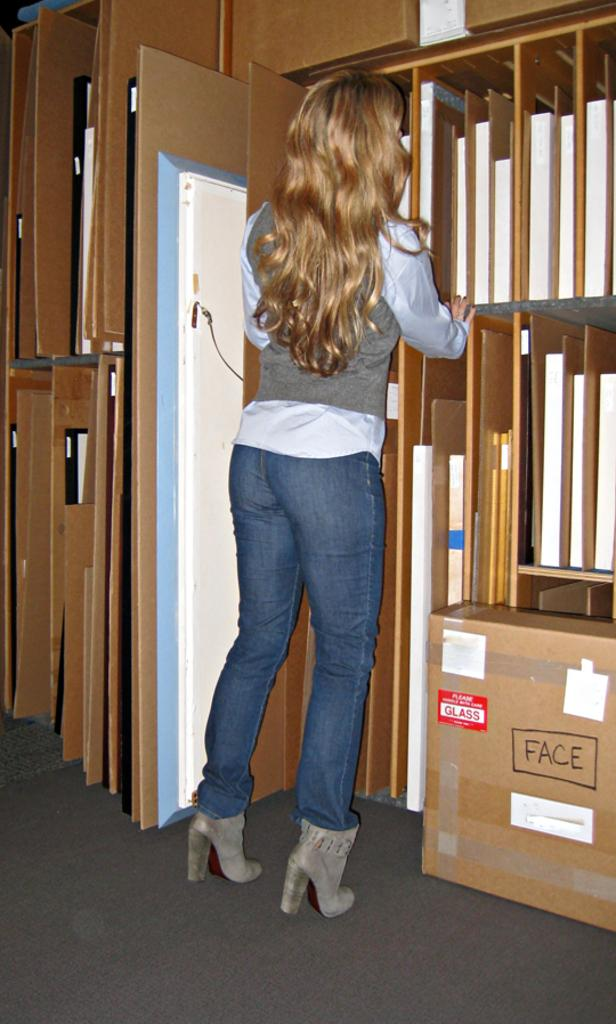<image>
Give a short and clear explanation of the subsequent image. The red tag on the box notifies your that there is glass inside 